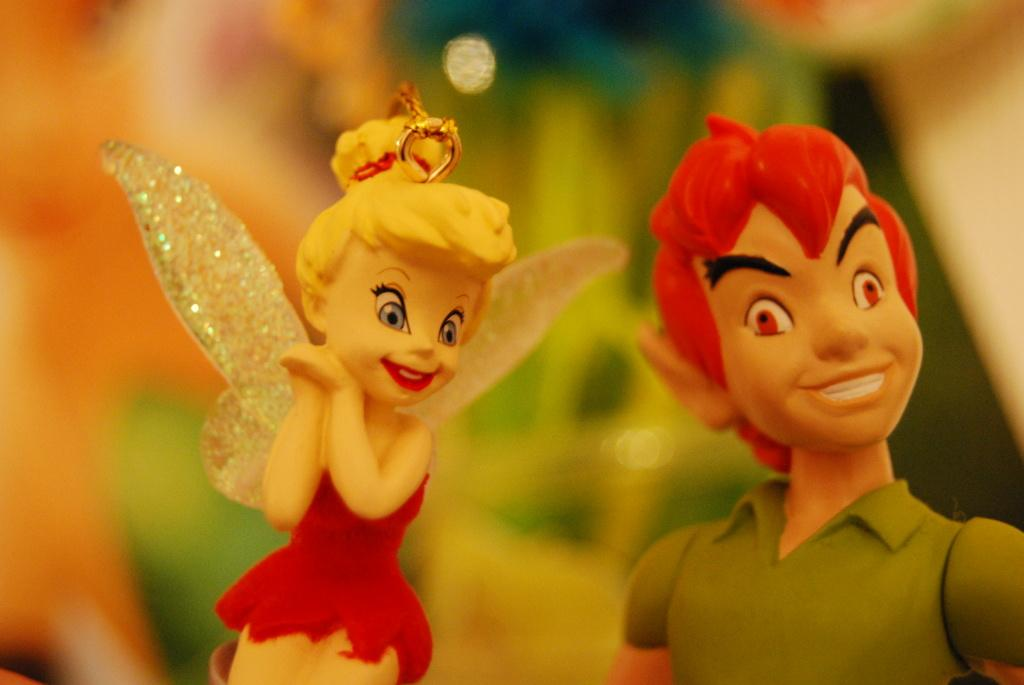How many toys can be seen in the image? There are 2 toys in the image. What feature do one of the toys have? One toy has wings. Can you describe the overall quality of the image? The image is blurred in the background. How would you describe the appearance of the toys? The toys are colorful. How does the toy with wings show respect to the other toy in the image? There is no indication in the image that the toys are capable of showing respect or interacting with each other in any way. 